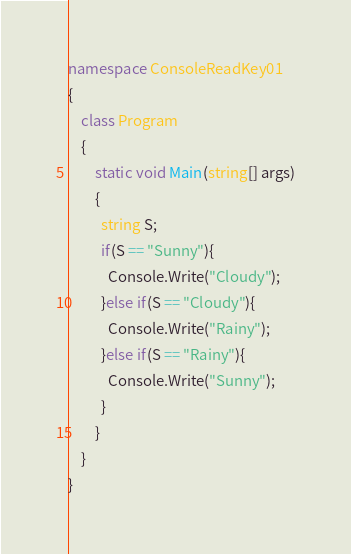<code> <loc_0><loc_0><loc_500><loc_500><_C#_>namespace ConsoleReadKey01
{
    class Program
    {
        static void Main(string[] args)
        {
          string S;
          if(S == "Sunny"){
            Console.Write("Cloudy");
          }else if(S == "Cloudy"){
            Console.Write("Rainy");
          }else if(S == "Rainy"){
            Console.Write("Sunny");
          }
        }
    }
}</code> 